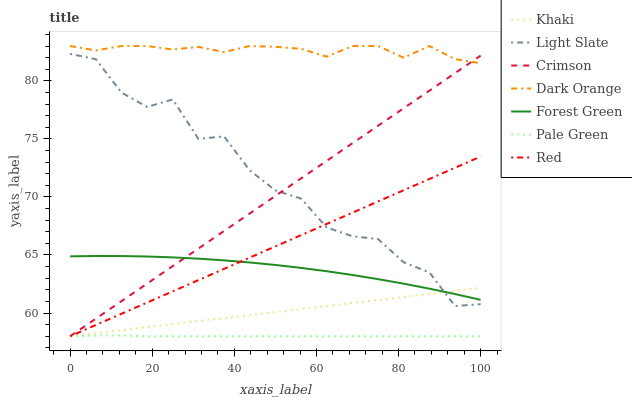Does Pale Green have the minimum area under the curve?
Answer yes or no. Yes. Does Dark Orange have the maximum area under the curve?
Answer yes or no. Yes. Does Khaki have the minimum area under the curve?
Answer yes or no. No. Does Khaki have the maximum area under the curve?
Answer yes or no. No. Is Khaki the smoothest?
Answer yes or no. Yes. Is Light Slate the roughest?
Answer yes or no. Yes. Is Light Slate the smoothest?
Answer yes or no. No. Is Khaki the roughest?
Answer yes or no. No. Does Khaki have the lowest value?
Answer yes or no. Yes. Does Light Slate have the lowest value?
Answer yes or no. No. Does Dark Orange have the highest value?
Answer yes or no. Yes. Does Khaki have the highest value?
Answer yes or no. No. Is Red less than Dark Orange?
Answer yes or no. Yes. Is Dark Orange greater than Light Slate?
Answer yes or no. Yes. Does Red intersect Crimson?
Answer yes or no. Yes. Is Red less than Crimson?
Answer yes or no. No. Is Red greater than Crimson?
Answer yes or no. No. Does Red intersect Dark Orange?
Answer yes or no. No. 